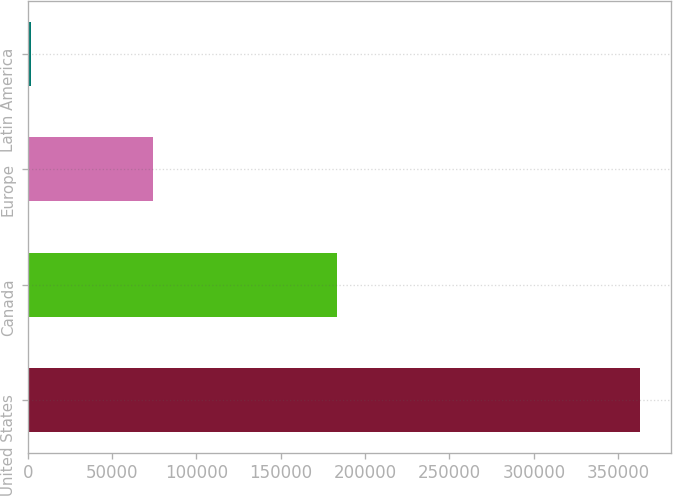Convert chart to OTSL. <chart><loc_0><loc_0><loc_500><loc_500><bar_chart><fcel>United States<fcel>Canada<fcel>Europe<fcel>Latin America<nl><fcel>362982<fcel>183219<fcel>74214<fcel>1737<nl></chart> 